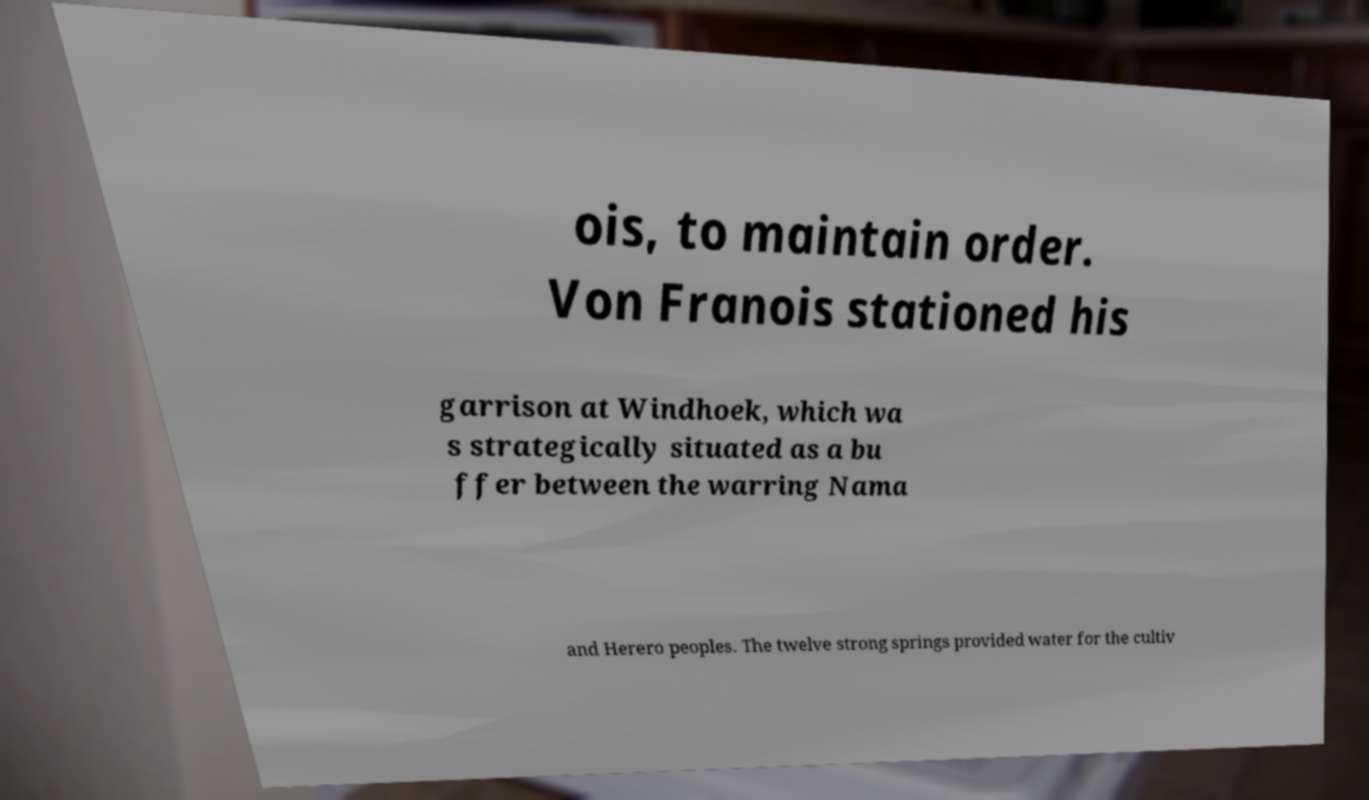Please read and relay the text visible in this image. What does it say? ois, to maintain order. Von Franois stationed his garrison at Windhoek, which wa s strategically situated as a bu ffer between the warring Nama and Herero peoples. The twelve strong springs provided water for the cultiv 